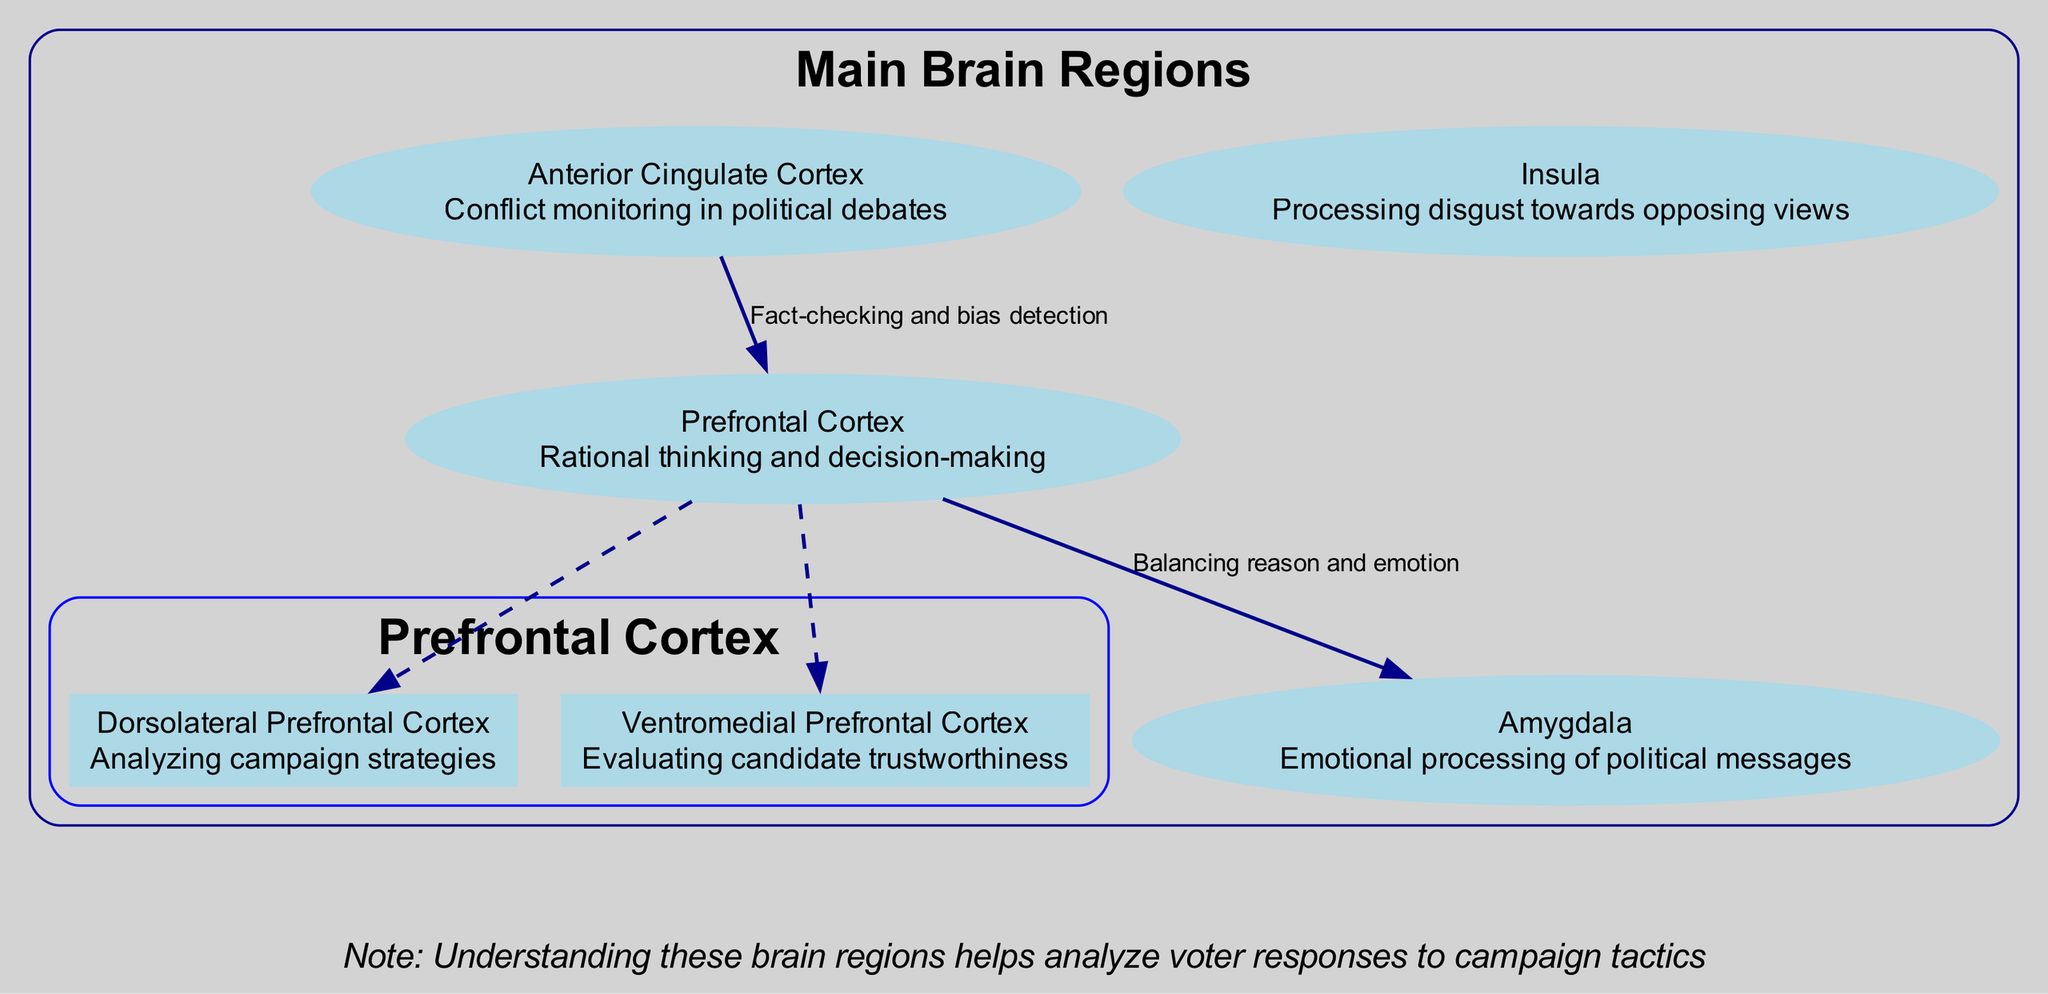What are the main components highlighted in the diagram? The diagram's data specifies four main brain regions involved in political decision-making: Prefrontal Cortex, Amygdala, Anterior Cingulate Cortex, and Insula.
Answer: Prefrontal Cortex, Amygdala, Anterior Cingulate Cortex, Insula Which subregion of the Prefrontal Cortex analyzes campaign strategies? According to the data, the Dorsolateral Prefrontal Cortex is specified as the subregion responsible for analyzing campaign strategies within the Prefrontal Cortex.
Answer: Dorsolateral Prefrontal Cortex How many connections are shown in the diagram? The information indicates there are two connections illustrated in the diagram: the connection from the Prefrontal Cortex to the Amygdala and from the Anterior Cingulate Cortex to the Prefrontal Cortex.
Answer: 2 What is the function of the Anterior Cingulate Cortex? The diagram indicates that the Anterior Cingulate Cortex is responsible for conflict monitoring in political debates, as detailed in the data provided.
Answer: Conflict monitoring in political debates What does the connection from the Prefrontal Cortex to the Amygdala represent? The connection described in the diagram indicates a relationship between the Prefrontal Cortex and the Amygdala, specifically balancing reason and emotion during political decision-making as outlined in the data.
Answer: Balancing reason and emotion How does the Anterior Cingulate Cortex contribute to political decision-making? The Anterior Cingulate Cortex is indicated to engage in conflict monitoring and serves a role in fact-checking and bias detection, reflecting its significant contribution to reasoning in political contexts as highlighted in the connections section.
Answer: Conflict monitoring, fact-checking, bias detection Which part of the brain processes disgust towards opposing views? The Insula is explicitly mentioned in the diagram data as the region responsible for processing feelings of disgust related to opposing political views.
Answer: Insula What role does the Ventromedial Prefrontal Cortex play in evaluating political candidates? The Ventromedial Prefrontal Cortex is described as responsible for evaluating candidate trustworthiness, showcasing its critical function in political decision-making.
Answer: Evaluating candidate trustworthiness 